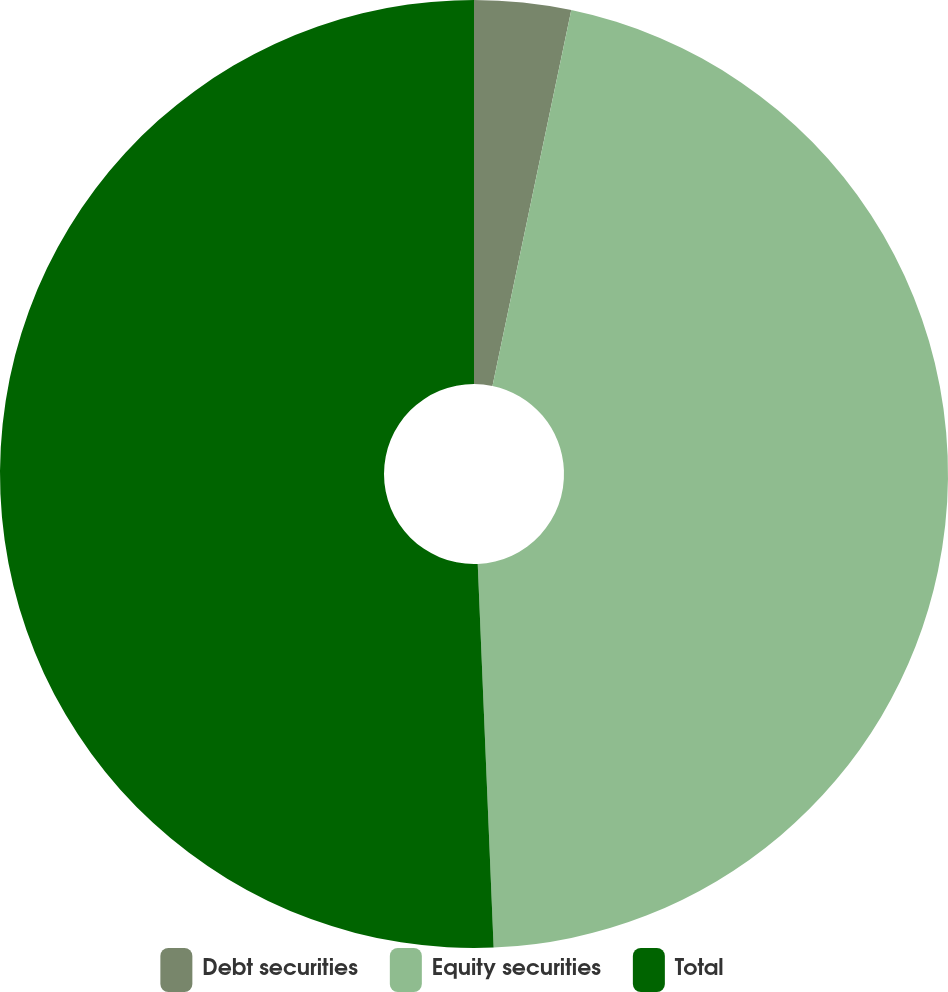Convert chart to OTSL. <chart><loc_0><loc_0><loc_500><loc_500><pie_chart><fcel>Debt securities<fcel>Equity securities<fcel>Total<nl><fcel>3.29%<fcel>46.05%<fcel>50.66%<nl></chart> 